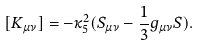<formula> <loc_0><loc_0><loc_500><loc_500>[ K _ { \mu \nu } ] = - \kappa _ { 5 } ^ { 2 } ( S _ { \mu \nu } - \frac { 1 } { 3 } g _ { \mu \nu } S ) .</formula> 